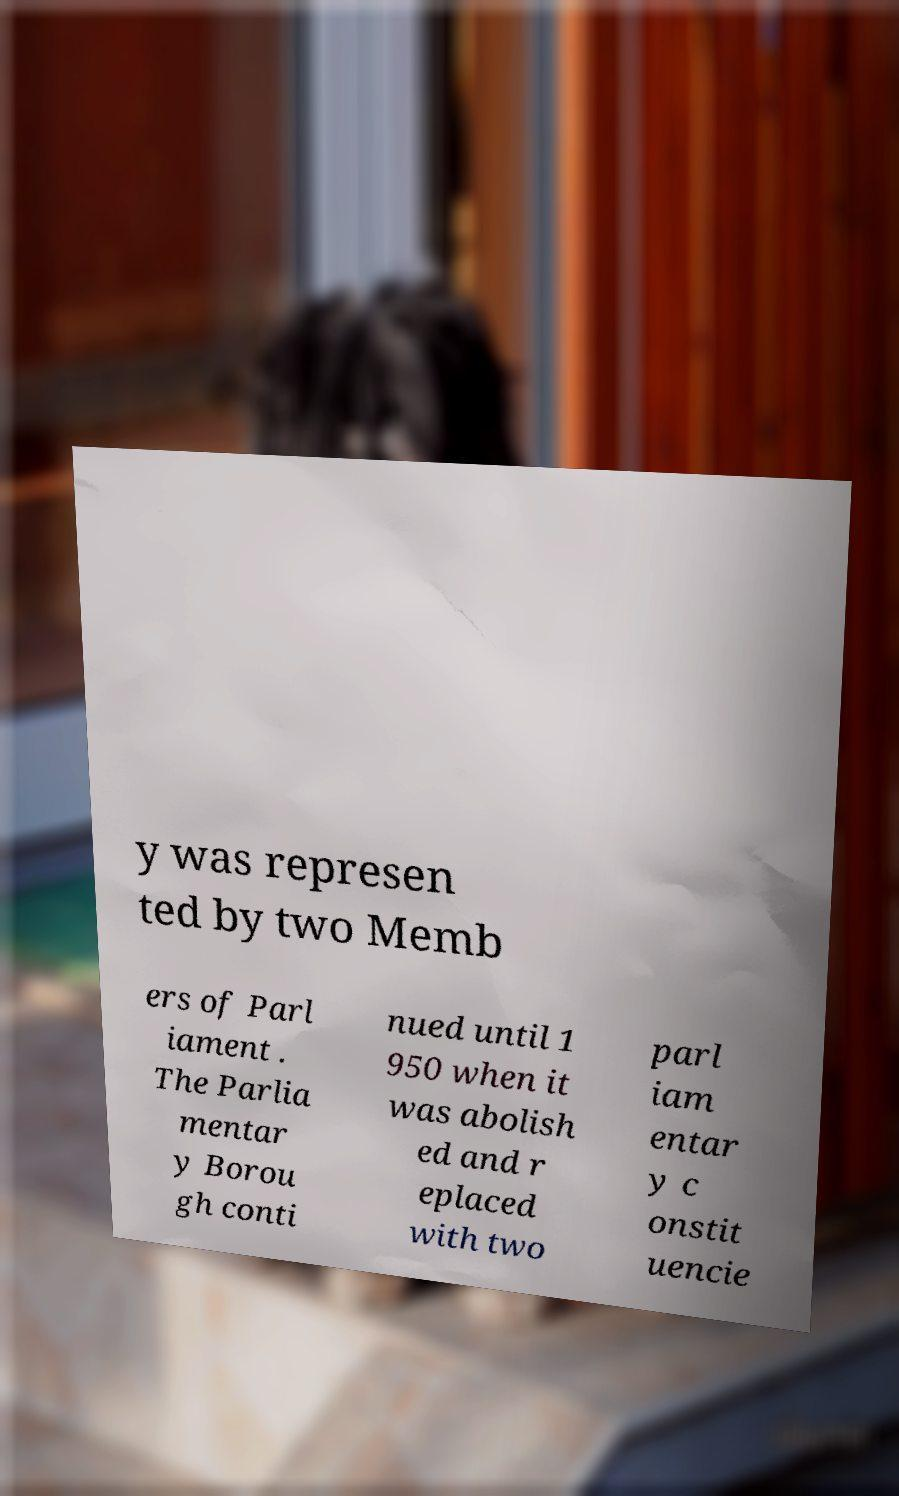Please identify and transcribe the text found in this image. y was represen ted by two Memb ers of Parl iament . The Parlia mentar y Borou gh conti nued until 1 950 when it was abolish ed and r eplaced with two parl iam entar y c onstit uencie 